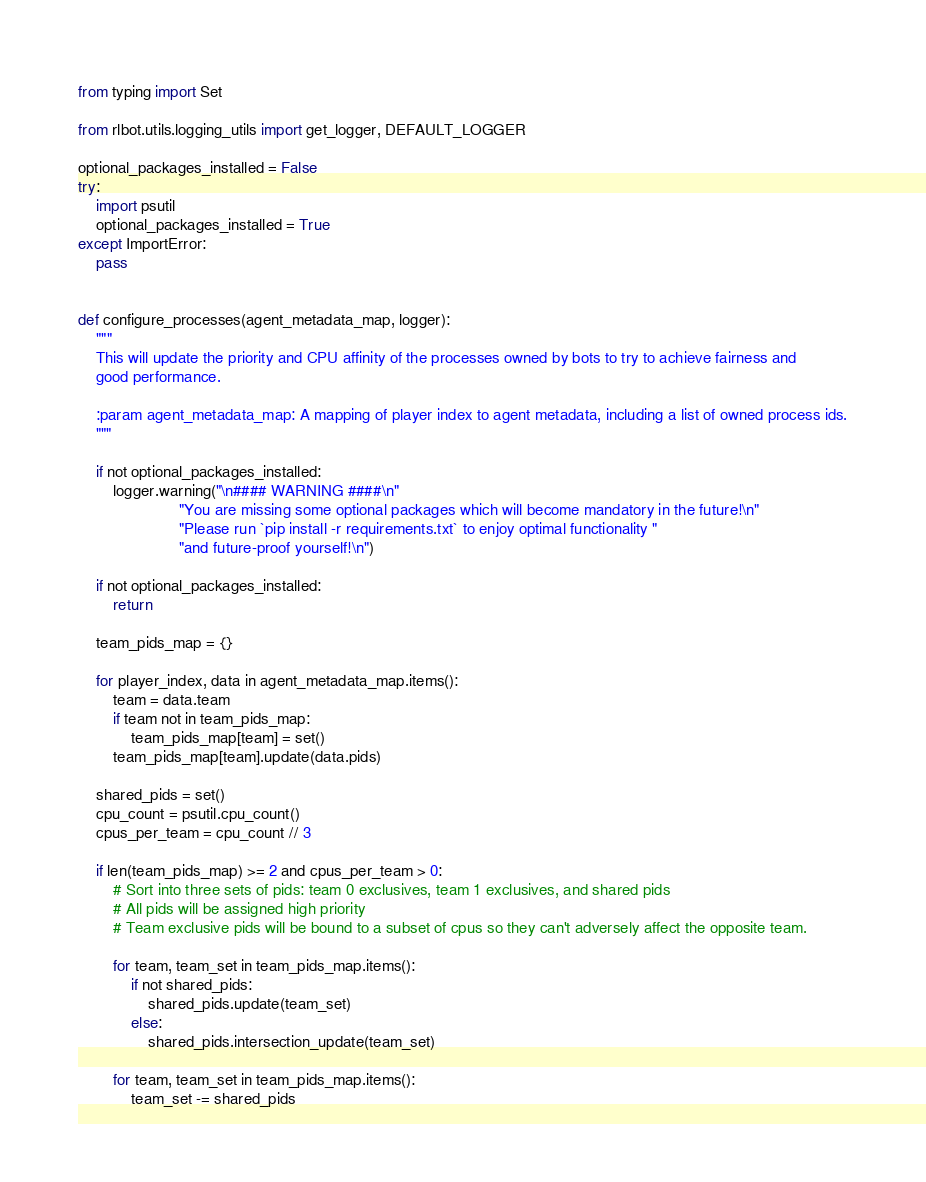Convert code to text. <code><loc_0><loc_0><loc_500><loc_500><_Python_>from typing import Set

from rlbot.utils.logging_utils import get_logger, DEFAULT_LOGGER

optional_packages_installed = False
try:
    import psutil
    optional_packages_installed = True
except ImportError:
    pass


def configure_processes(agent_metadata_map, logger):
    """
    This will update the priority and CPU affinity of the processes owned by bots to try to achieve fairness and
    good performance.

    :param agent_metadata_map: A mapping of player index to agent metadata, including a list of owned process ids.
    """

    if not optional_packages_installed:
        logger.warning("\n#### WARNING ####\n"
                       "You are missing some optional packages which will become mandatory in the future!\n"
                       "Please run `pip install -r requirements.txt` to enjoy optimal functionality "
                       "and future-proof yourself!\n")

    if not optional_packages_installed:
        return

    team_pids_map = {}

    for player_index, data in agent_metadata_map.items():
        team = data.team
        if team not in team_pids_map:
            team_pids_map[team] = set()
        team_pids_map[team].update(data.pids)

    shared_pids = set()
    cpu_count = psutil.cpu_count()
    cpus_per_team = cpu_count // 3

    if len(team_pids_map) >= 2 and cpus_per_team > 0:
        # Sort into three sets of pids: team 0 exclusives, team 1 exclusives, and shared pids
        # All pids will be assigned high priority
        # Team exclusive pids will be bound to a subset of cpus so they can't adversely affect the opposite team.

        for team, team_set in team_pids_map.items():
            if not shared_pids:
                shared_pids.update(team_set)
            else:
                shared_pids.intersection_update(team_set)

        for team, team_set in team_pids_map.items():
            team_set -= shared_pids
</code> 